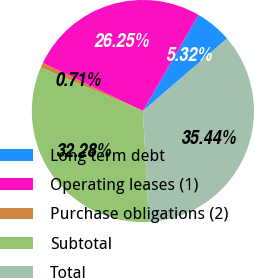<chart> <loc_0><loc_0><loc_500><loc_500><pie_chart><fcel>Long term debt<fcel>Operating leases (1)<fcel>Purchase obligations (2)<fcel>Subtotal<fcel>Total<nl><fcel>5.32%<fcel>26.25%<fcel>0.71%<fcel>32.28%<fcel>35.44%<nl></chart> 